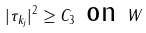<formula> <loc_0><loc_0><loc_500><loc_500>| \tau _ { k _ { j } } | ^ { 2 } \geq C _ { 3 } \text {  on } W</formula> 